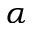<formula> <loc_0><loc_0><loc_500><loc_500>\alpha</formula> 